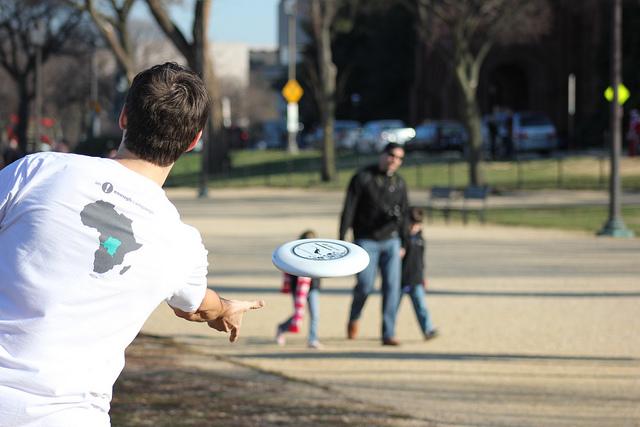What did the man just throw?
Concise answer only. Frisbee. What color is his shirt?
Short answer required. White. What is on the man's shirt?
Quick response, please. Africa. 